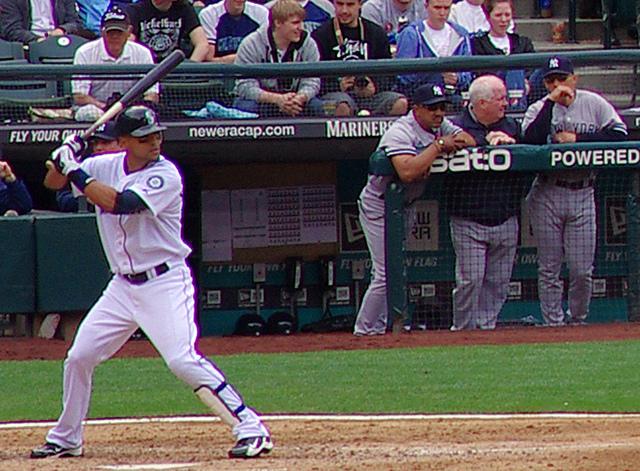What game is being played?
Write a very short answer. Baseball. What is the player holding?
Give a very brief answer. Bat. What language can be seen on the signs?
Keep it brief. English. Is the man running?
Be succinct. No. 